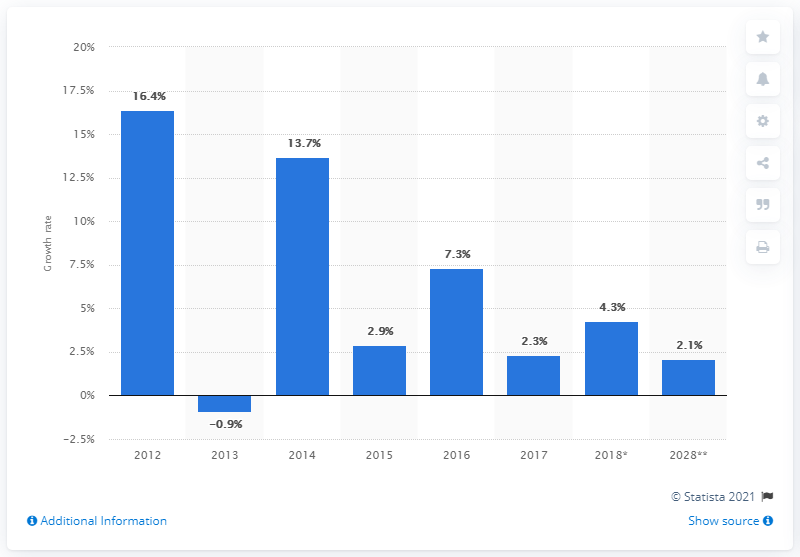Mention a couple of crucial points in this snapshot. The year with the most negative blue bars is 2013. In 2013, there was a significant decrease in the growth rate of capital investment, which represented a significant setback for the economy at the time. 